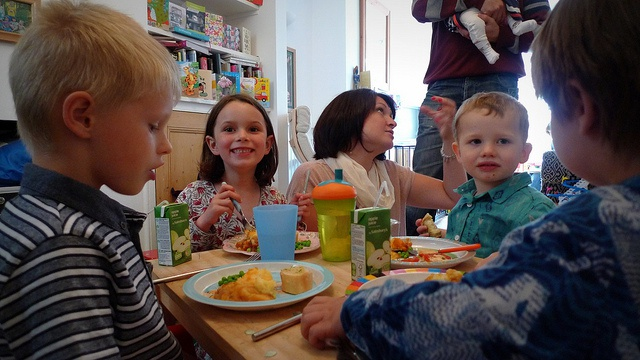Describe the objects in this image and their specific colors. I can see people in black, maroon, and gray tones, people in black, gray, navy, and maroon tones, people in black, gray, and darkgray tones, people in black, brown, and maroon tones, and people in black, teal, and gray tones in this image. 